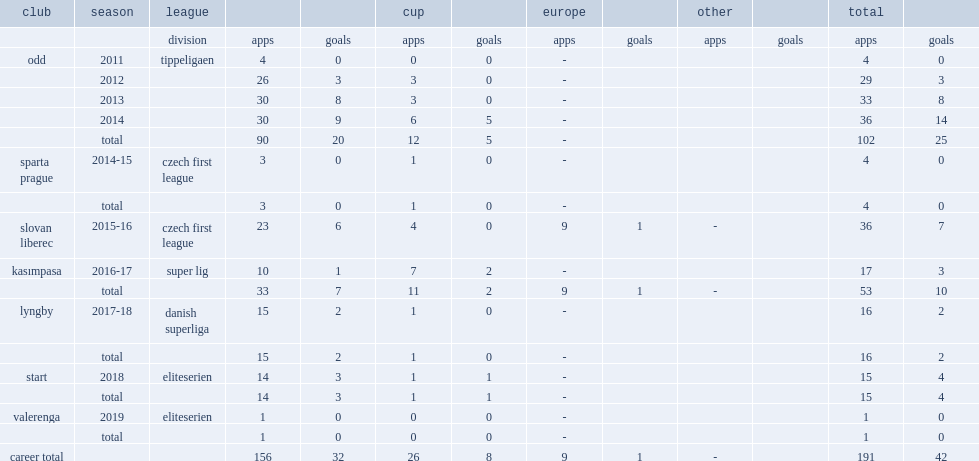Which club did shala play for in 2018? Start. 